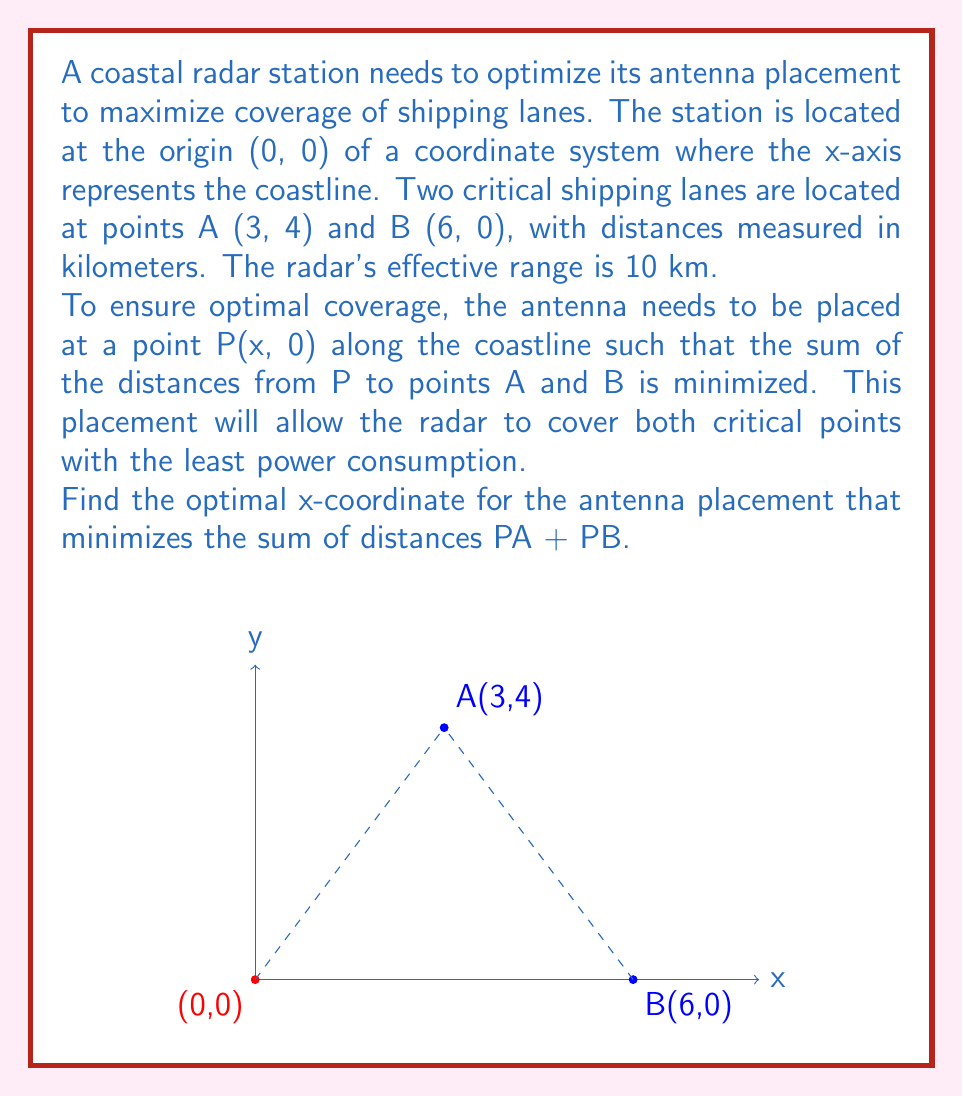Show me your answer to this math problem. Let's approach this step-by-step:

1) Let the antenna be placed at point P(x, 0) on the x-axis.

2) The distance PA can be calculated using the distance formula:
   $$PA = \sqrt{(x-3)^2 + 4^2}$$

3) Similarly, the distance PB is:
   $$PB = \sqrt{(x-6)^2 + 0^2} = |x-6|$$

4) We want to minimize the sum of these distances:
   $$f(x) = PA + PB = \sqrt{(x-3)^2 + 16} + |x-6|$$

5) To find the minimum, we need to find where the derivative of this function equals zero. However, the absolute value function makes this difficult to differentiate directly.

6) Instead, we can use the property that the optimal point will be where PA = PB. This is because if one distance was shorter, we could always improve by moving slightly towards the farther point.

7) Setting PA = PB:
   $$\sqrt{(x-3)^2 + 16} = |x-6|$$

8) Squaring both sides (valid since both sides are non-negative):
   $$(x-3)^2 + 16 = (x-6)^2$$

9) Expanding:
   $$x^2 - 6x + 9 + 16 = x^2 - 12x + 36$$

10) Simplifying:
    $$x^2 - 6x + 25 = x^2 - 12x + 36$$
    $$6x = 11$$
    $$x = \frac{11}{6} \approx 1.83$$

11) We can verify this is a minimum by checking values on either side.

Therefore, the optimal x-coordinate for the antenna placement is $\frac{11}{6}$ km along the coastline from the origin.
Answer: $\frac{11}{6}$ km 